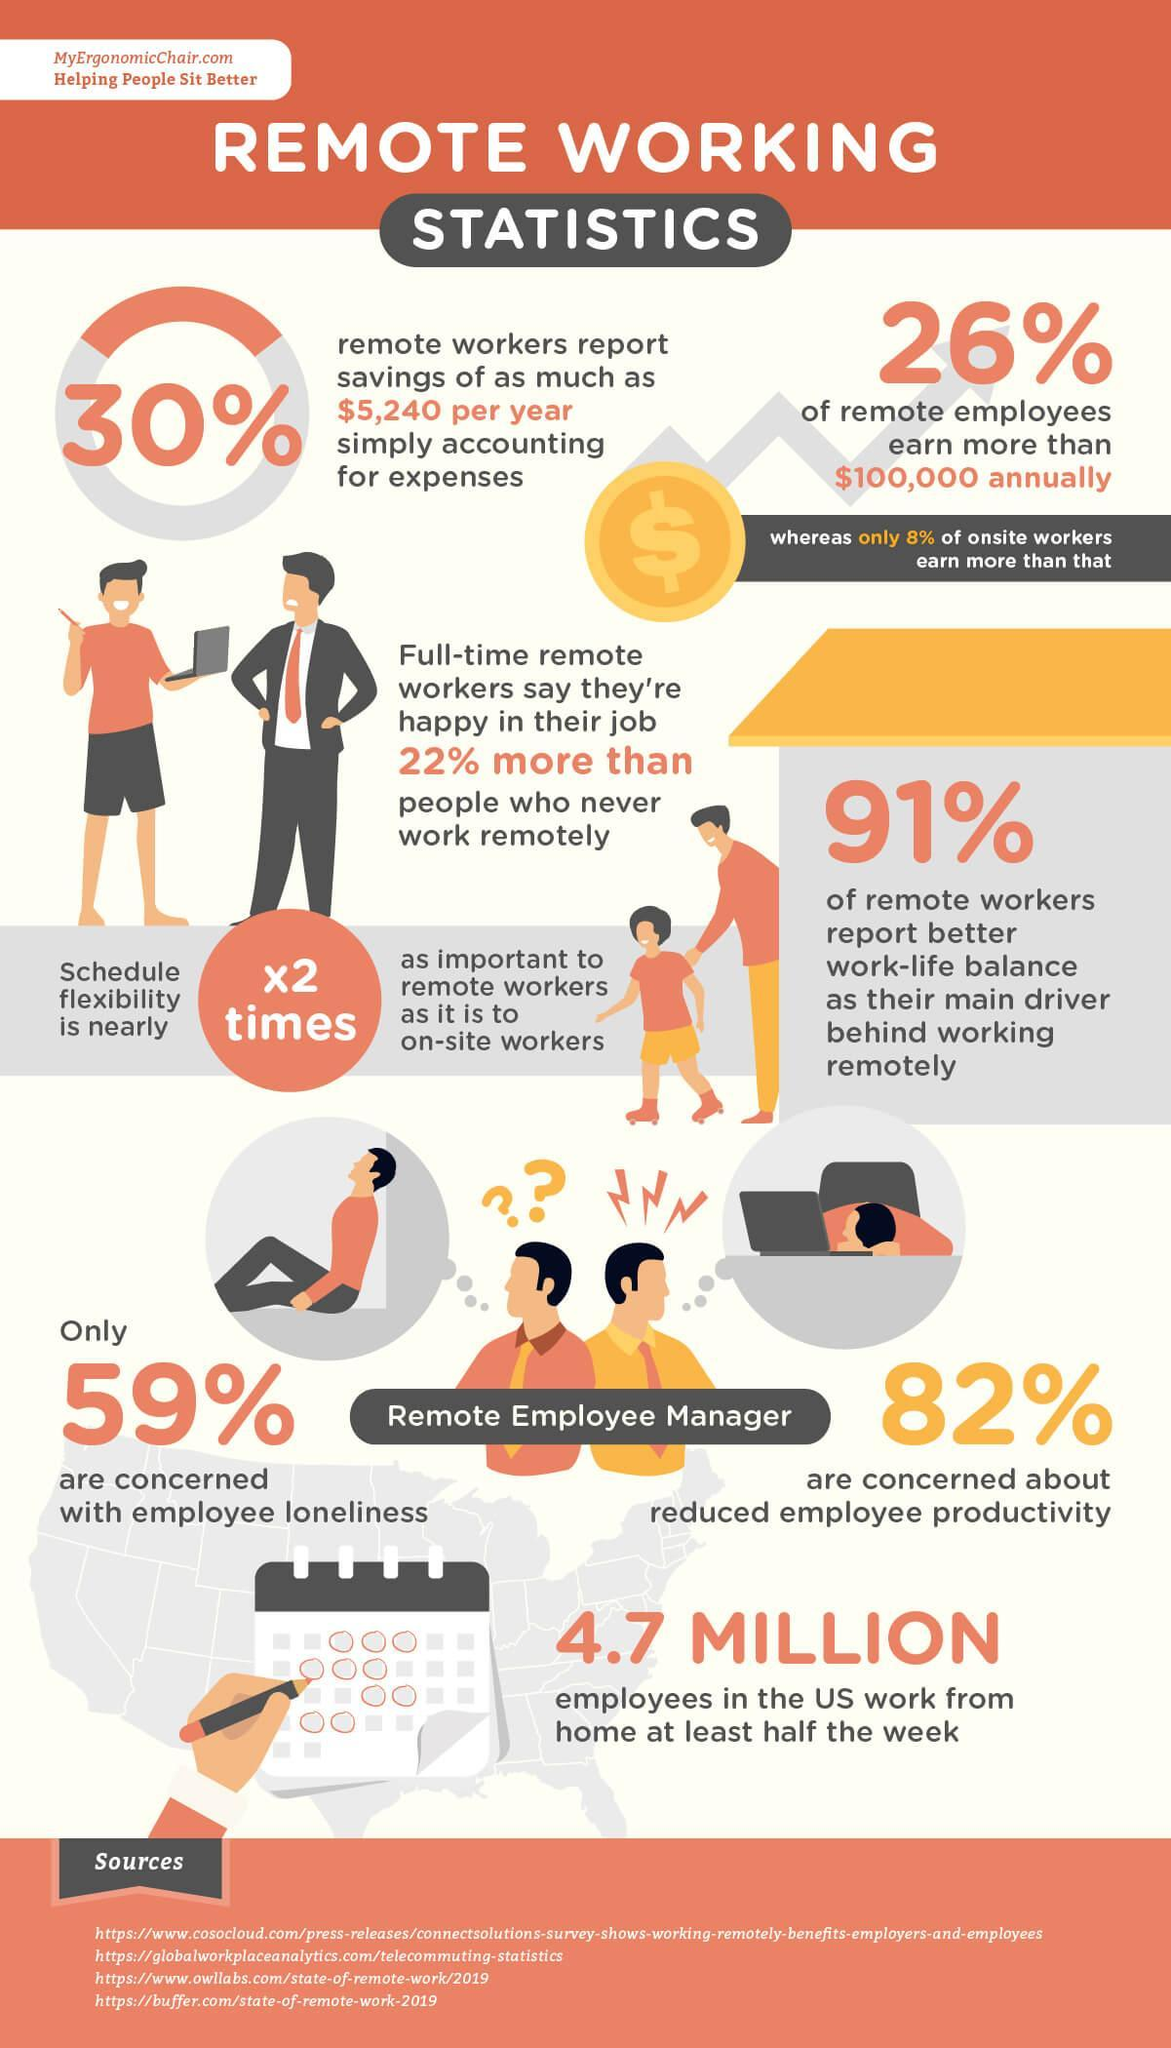What percent of remote employees earn less than $100,000 annually?
Answer the question with a short phrase. 74% How many websites are listed as sources? 4 What percent are not concerned with employee loneliness? 41% 